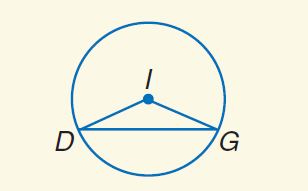Question: Find \widehat D G if m \angle D G I = 24 and r = 6.
Choices:
A. 6
B. \frac { 22 } { 5 } \pi
C. 24
D. 24 \pi
Answer with the letter. Answer: B 